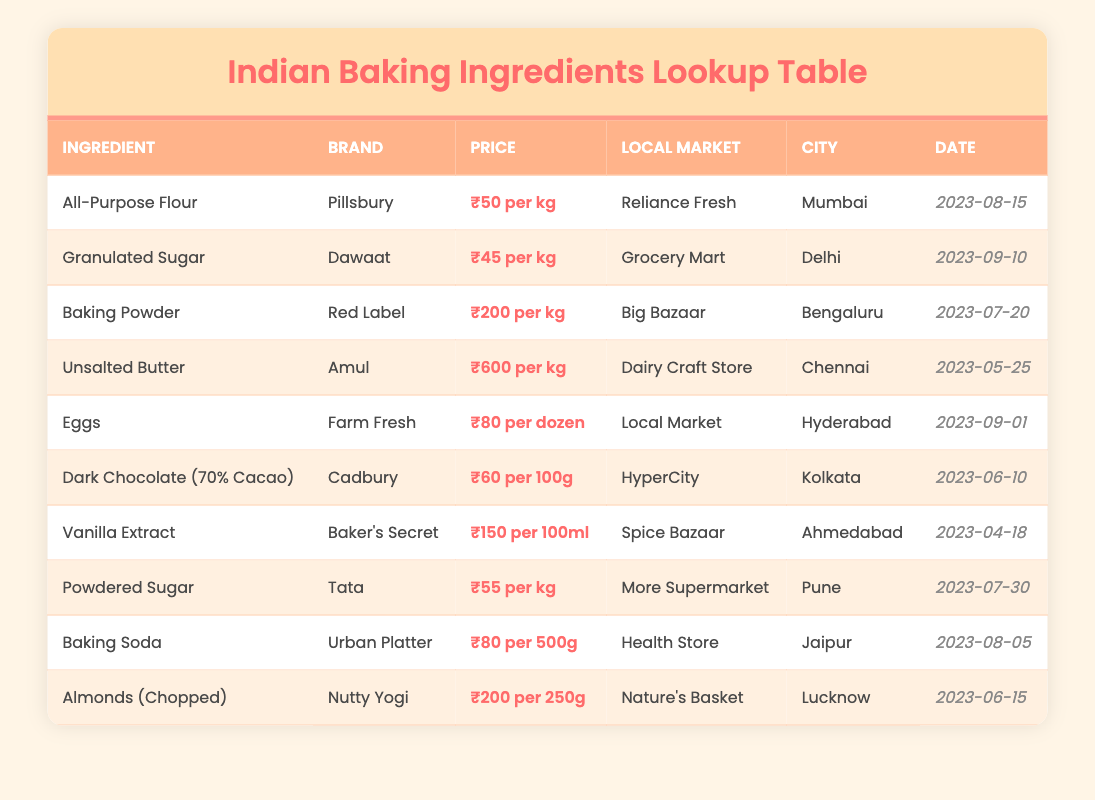What is the price of Unsalted Butter per kg? The table lists Unsalted Butter under the ingredient column with the corresponding price noted as ₹600 per kg.
Answer: ₹600 per kg Which city has the cheapest Granulated Sugar listed? Granulated Sugar is available in Delhi at ₹45 per kg. There are no other entries for Granulated Sugar, so this is the cheapest.
Answer: Delhi How much do 12 eggs cost in Hyderabad? The price for a dozen eggs in Hyderabad is given as ₹80 per dozen from the Local Market, as mentioned in the table.
Answer: ₹80 per dozen What is the total price for 1 kg of All-Purpose Flour and 500g of Baking Soda? The price for All-Purpose Flour is ₹50 per kg and for Baking Soda is ₹80 per 500g. First, convert 500g into kg, which is 0.5 kg. Thus, the total is ₹50 + ₹80 (which is half the kg, so we adjust) = ₹50 + ₹160 = ₹210.
Answer: ₹210 Is Baking Powder more expensive than Unsalted Butter? Baking Powder is priced at ₹200 per kg and Unsalted Butter is priced at ₹600 per kg. Since 600 is greater than 200, Baking Powder is not more expensive.
Answer: No Who sells the cheapest Powdered Sugar and what is the price? The cheapest Powdered Sugar is from Tata at ₹55 per kg, listed under the More Supermarket in Pune. It's the only entry for Powdered Sugar in the table, confirming it's the cheapest.
Answer: ₹55 per kg In which city is Dark Chocolate the most expensive per 100g? Dark Chocolate (70% Cacao) from Cadbury is priced at ₹60 per 100g in Kolkata. This is the only price listed for Dark Chocolate in the table, so it is concluded as the most expensive for this ingredient.
Answer: Kolkata What are the prices of both Almonds (Chopped) and Dark Chocolate? Almonds are listed at ₹200 per 250g and Dark Chocolate is priced at ₹60 per 100g. To compare directly, convert Almonds to a per 100g price: ₹200 per 250g = ₹80 per 100g (200/2.5). Thus, Almonds cost ₹80 for every 100g and Dark Chocolate is ₹60 per 100g. Dark Chocolate is cheaper than Almonds.
Answer: Dark Chocolate is cheaper What percentage of the listed ingredients are priced over ₹100? First, count the ingredients priced over ₹100: Baking Powder (₹200), Unsalted Butter (₹600), Almonds (₹200), and Vanilla Extract (₹150). That gives us 4 ingredients. The total number of ingredients is 10. To find the percentage, (4/10)*100 = 40%.
Answer: 40% 